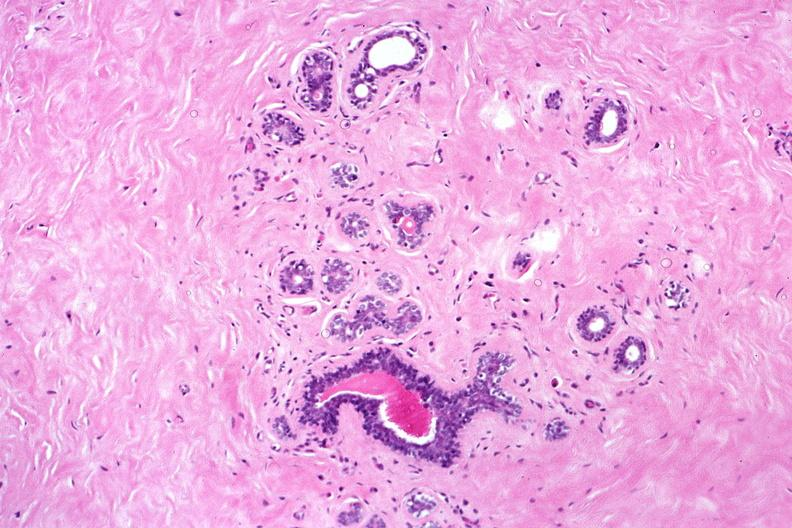does acid show normal breast?
Answer the question using a single word or phrase. No 